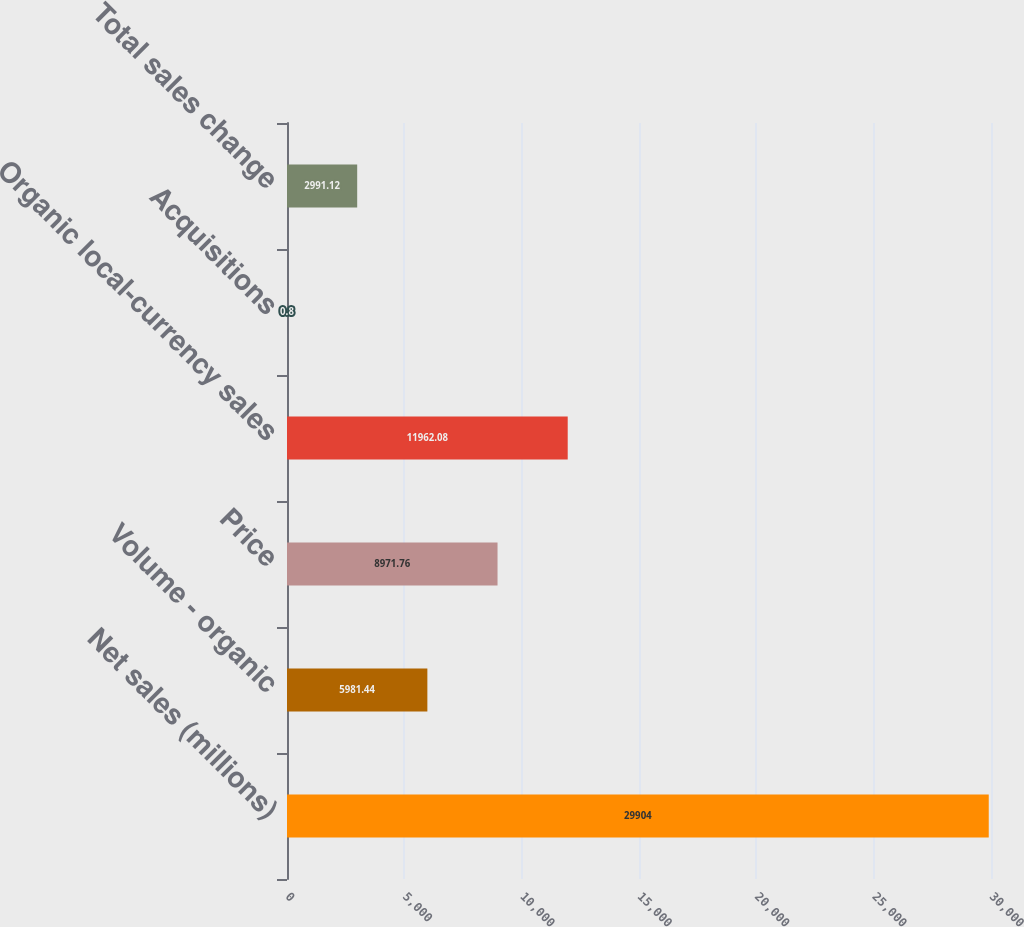<chart> <loc_0><loc_0><loc_500><loc_500><bar_chart><fcel>Net sales (millions)<fcel>Volume - organic<fcel>Price<fcel>Organic local-currency sales<fcel>Acquisitions<fcel>Total sales change<nl><fcel>29904<fcel>5981.44<fcel>8971.76<fcel>11962.1<fcel>0.8<fcel>2991.12<nl></chart> 